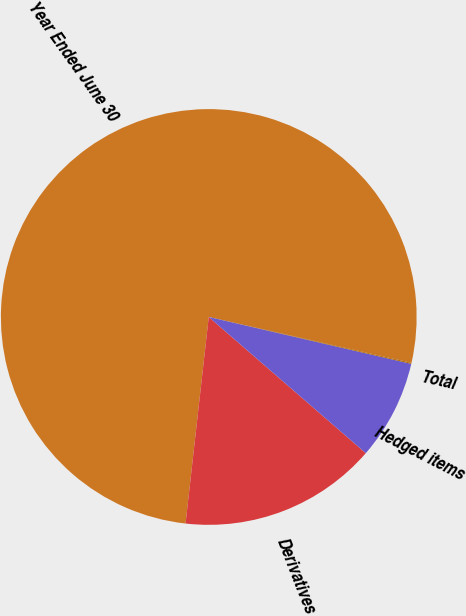Convert chart. <chart><loc_0><loc_0><loc_500><loc_500><pie_chart><fcel>Year Ended June 30<fcel>Derivatives<fcel>Hedged items<fcel>Total<nl><fcel>76.76%<fcel>15.41%<fcel>7.75%<fcel>0.08%<nl></chart> 